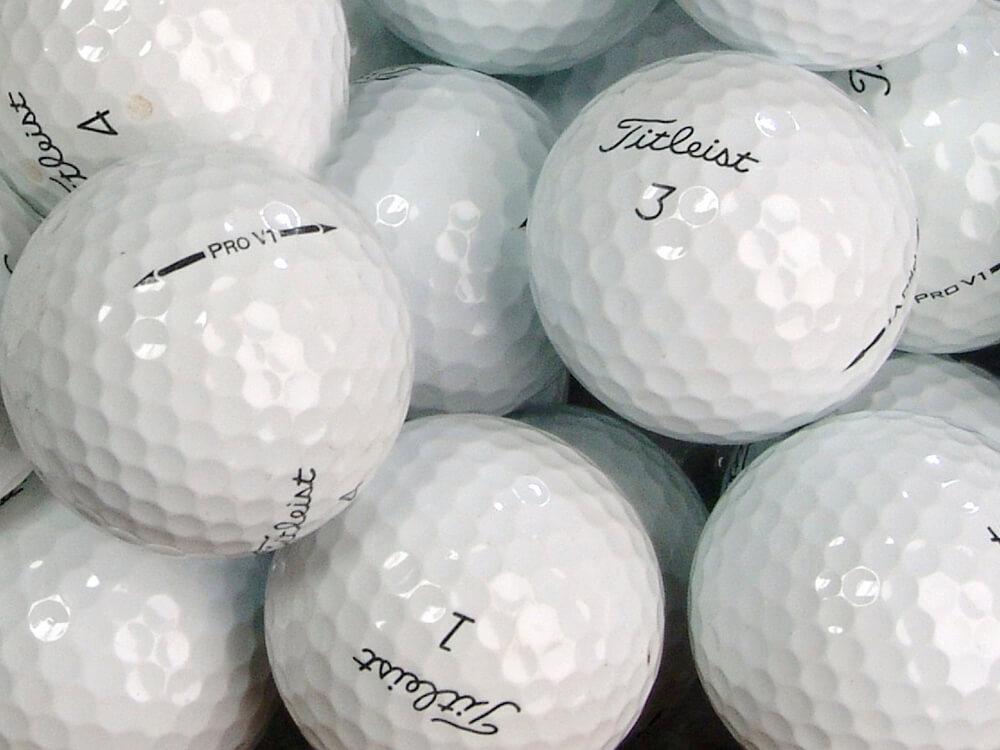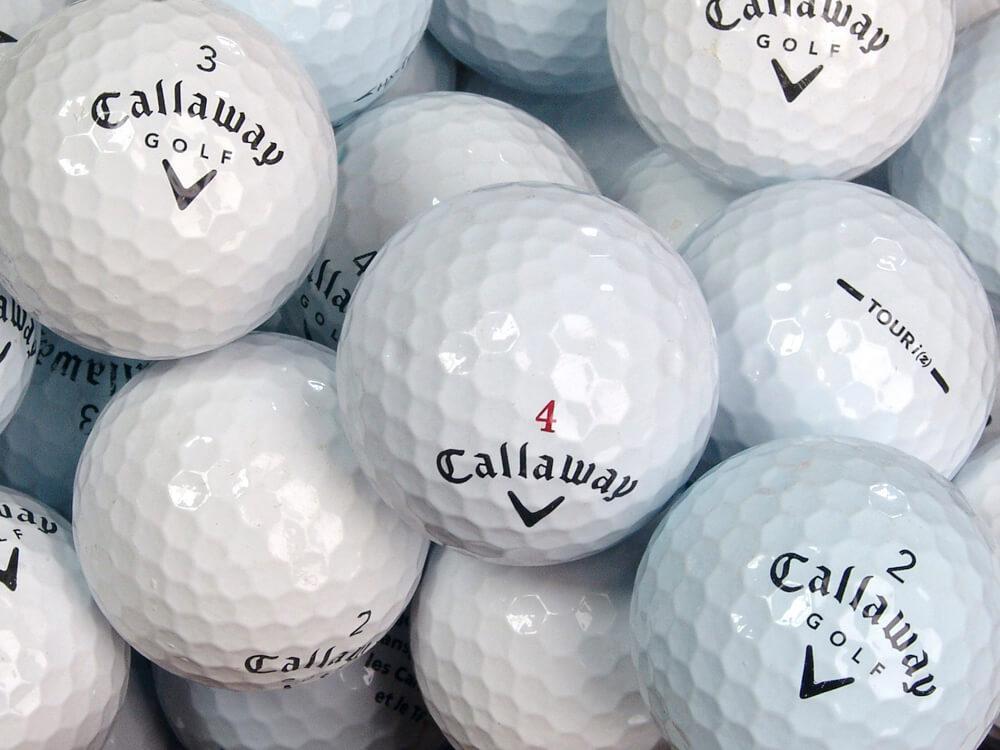The first image is the image on the left, the second image is the image on the right. Examine the images to the left and right. Is the description "The left and right image contains a total of two golf balls." accurate? Answer yes or no. No. The first image is the image on the left, the second image is the image on the right. Analyze the images presented: Is the assertion "All balls are white and all balls have round-dimpled surfaces." valid? Answer yes or no. Yes. 